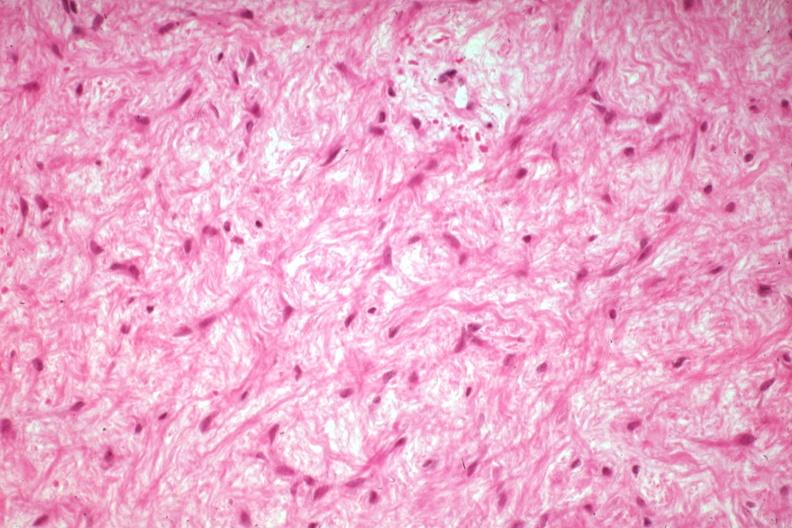what is present?
Answer the question using a single word or phrase. Joints 